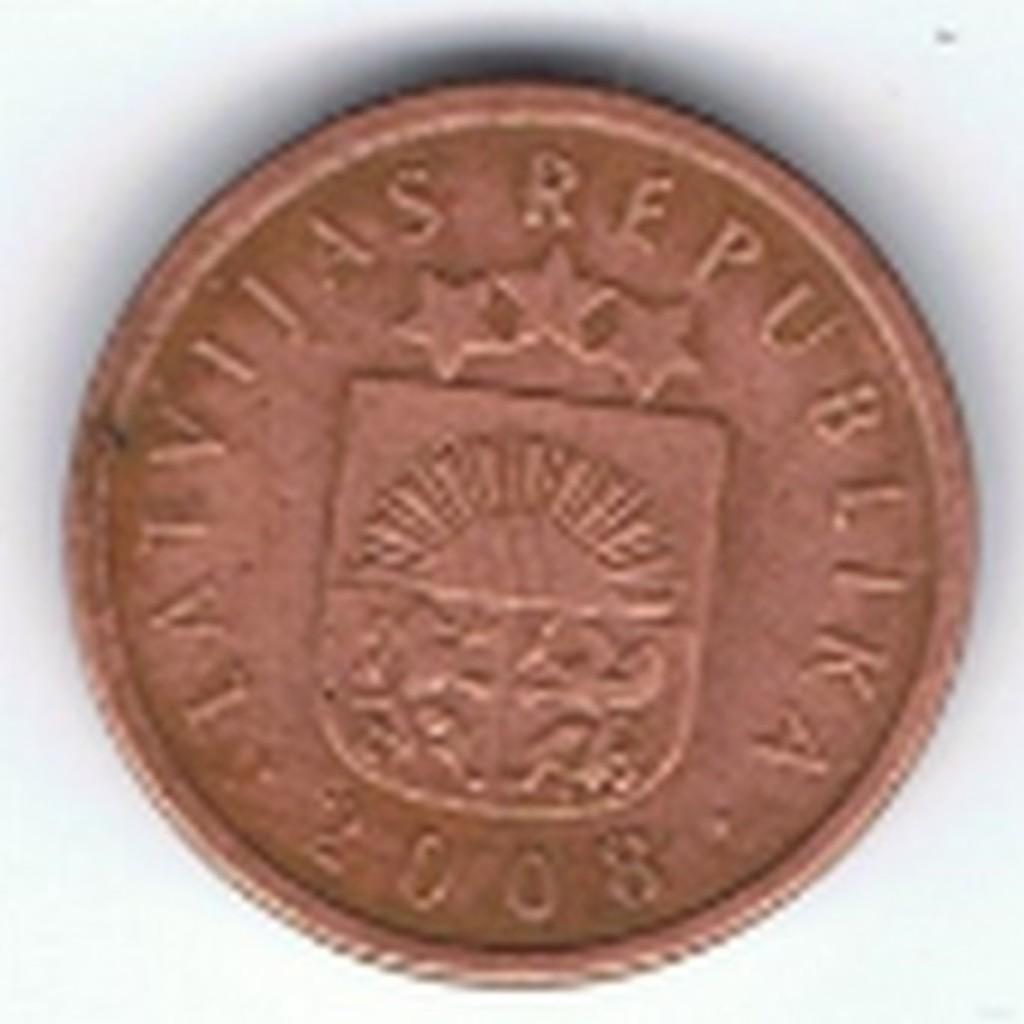<image>
Create a compact narrative representing the image presented. The bronze coin has 2008 printed on it's face 